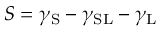<formula> <loc_0><loc_0><loc_500><loc_500>S = \gamma _ { S } - \gamma _ { S L } - \gamma _ { L }</formula> 